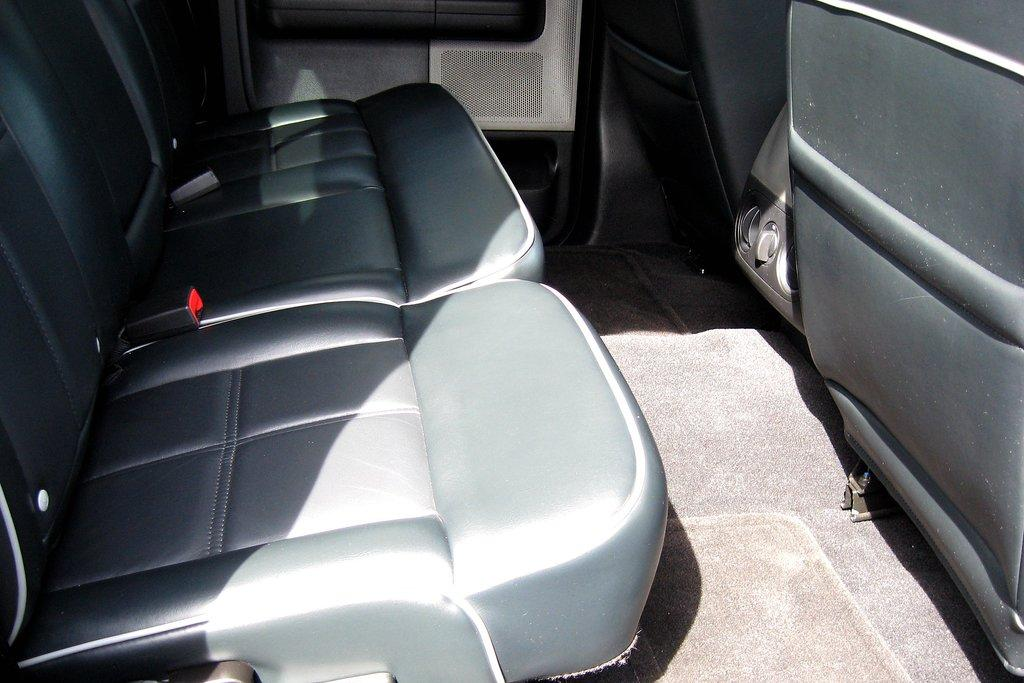What is the main subject of the image? There is a vehicle in the image. What can be found on both sides of the vehicle? The vehicle has seats on the left side and seats on the right side. What is present at the bottom of the vehicle? There is a floor or mat at the bottom of the vehicle. Can you describe any openings or entrances in the image? There is a door visible in the background of the image. What type of spade is being used to dig in the image? There is no spade present in the image; it features a vehicle with seats and a door. How many wings can be seen on the vehicle in the image? Vehicles typically do not have wings, so there are no wings visible in the image. 